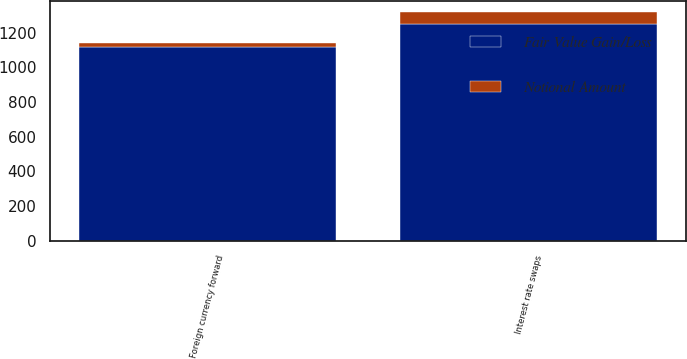<chart> <loc_0><loc_0><loc_500><loc_500><stacked_bar_chart><ecel><fcel>Foreign currency forward<fcel>Interest rate swaps<nl><fcel>Fair Value Gain/Loss<fcel>1117.8<fcel>1250<nl><fcel>Notional Amount<fcel>21.8<fcel>68.7<nl></chart> 